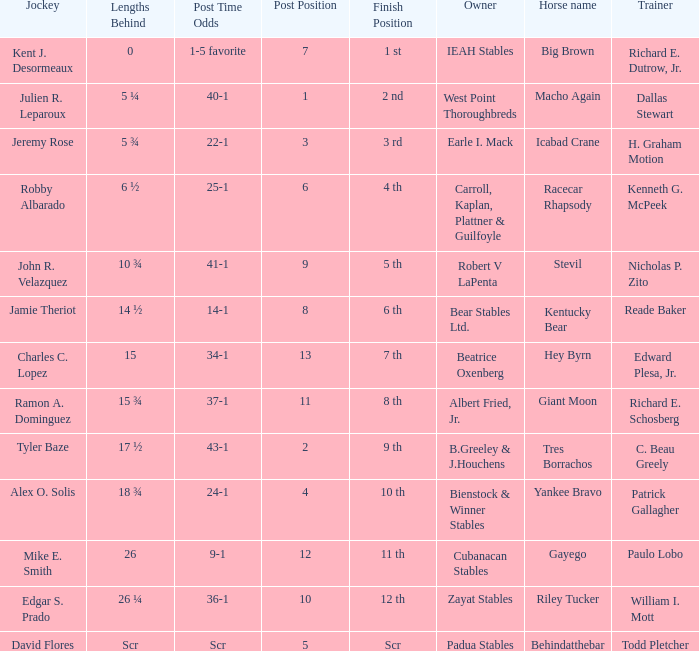What's the lengths behind of Jockey Ramon A. Dominguez? 15 ¾. 